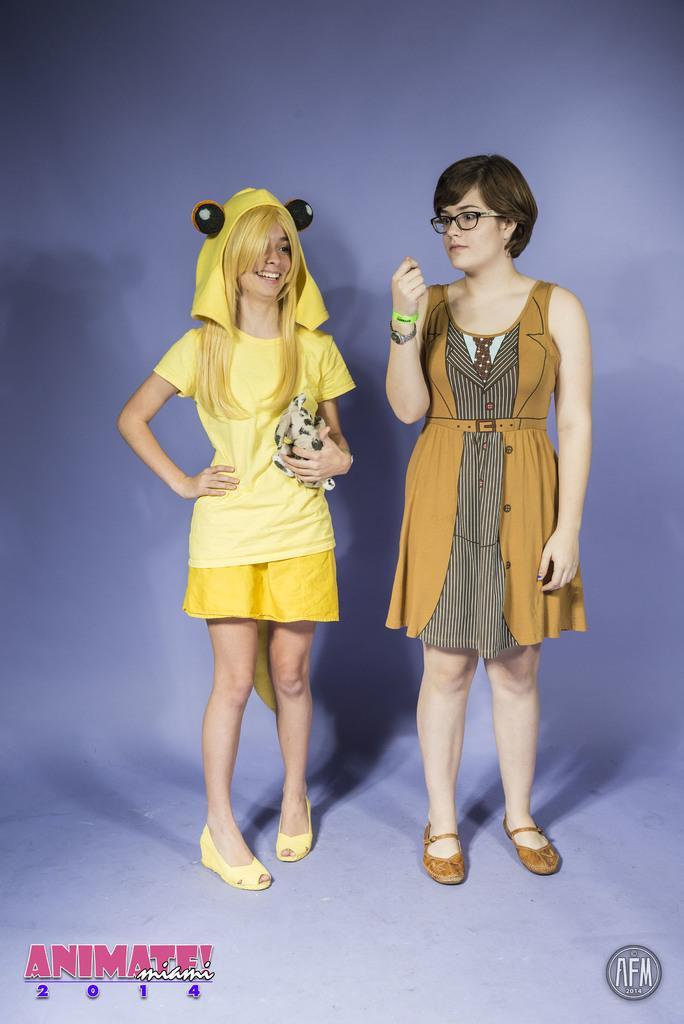How would you summarize this image in a sentence or two? In this image there are two girls standing, one of the girls is holding a toy in her hand with a smile on her face. 